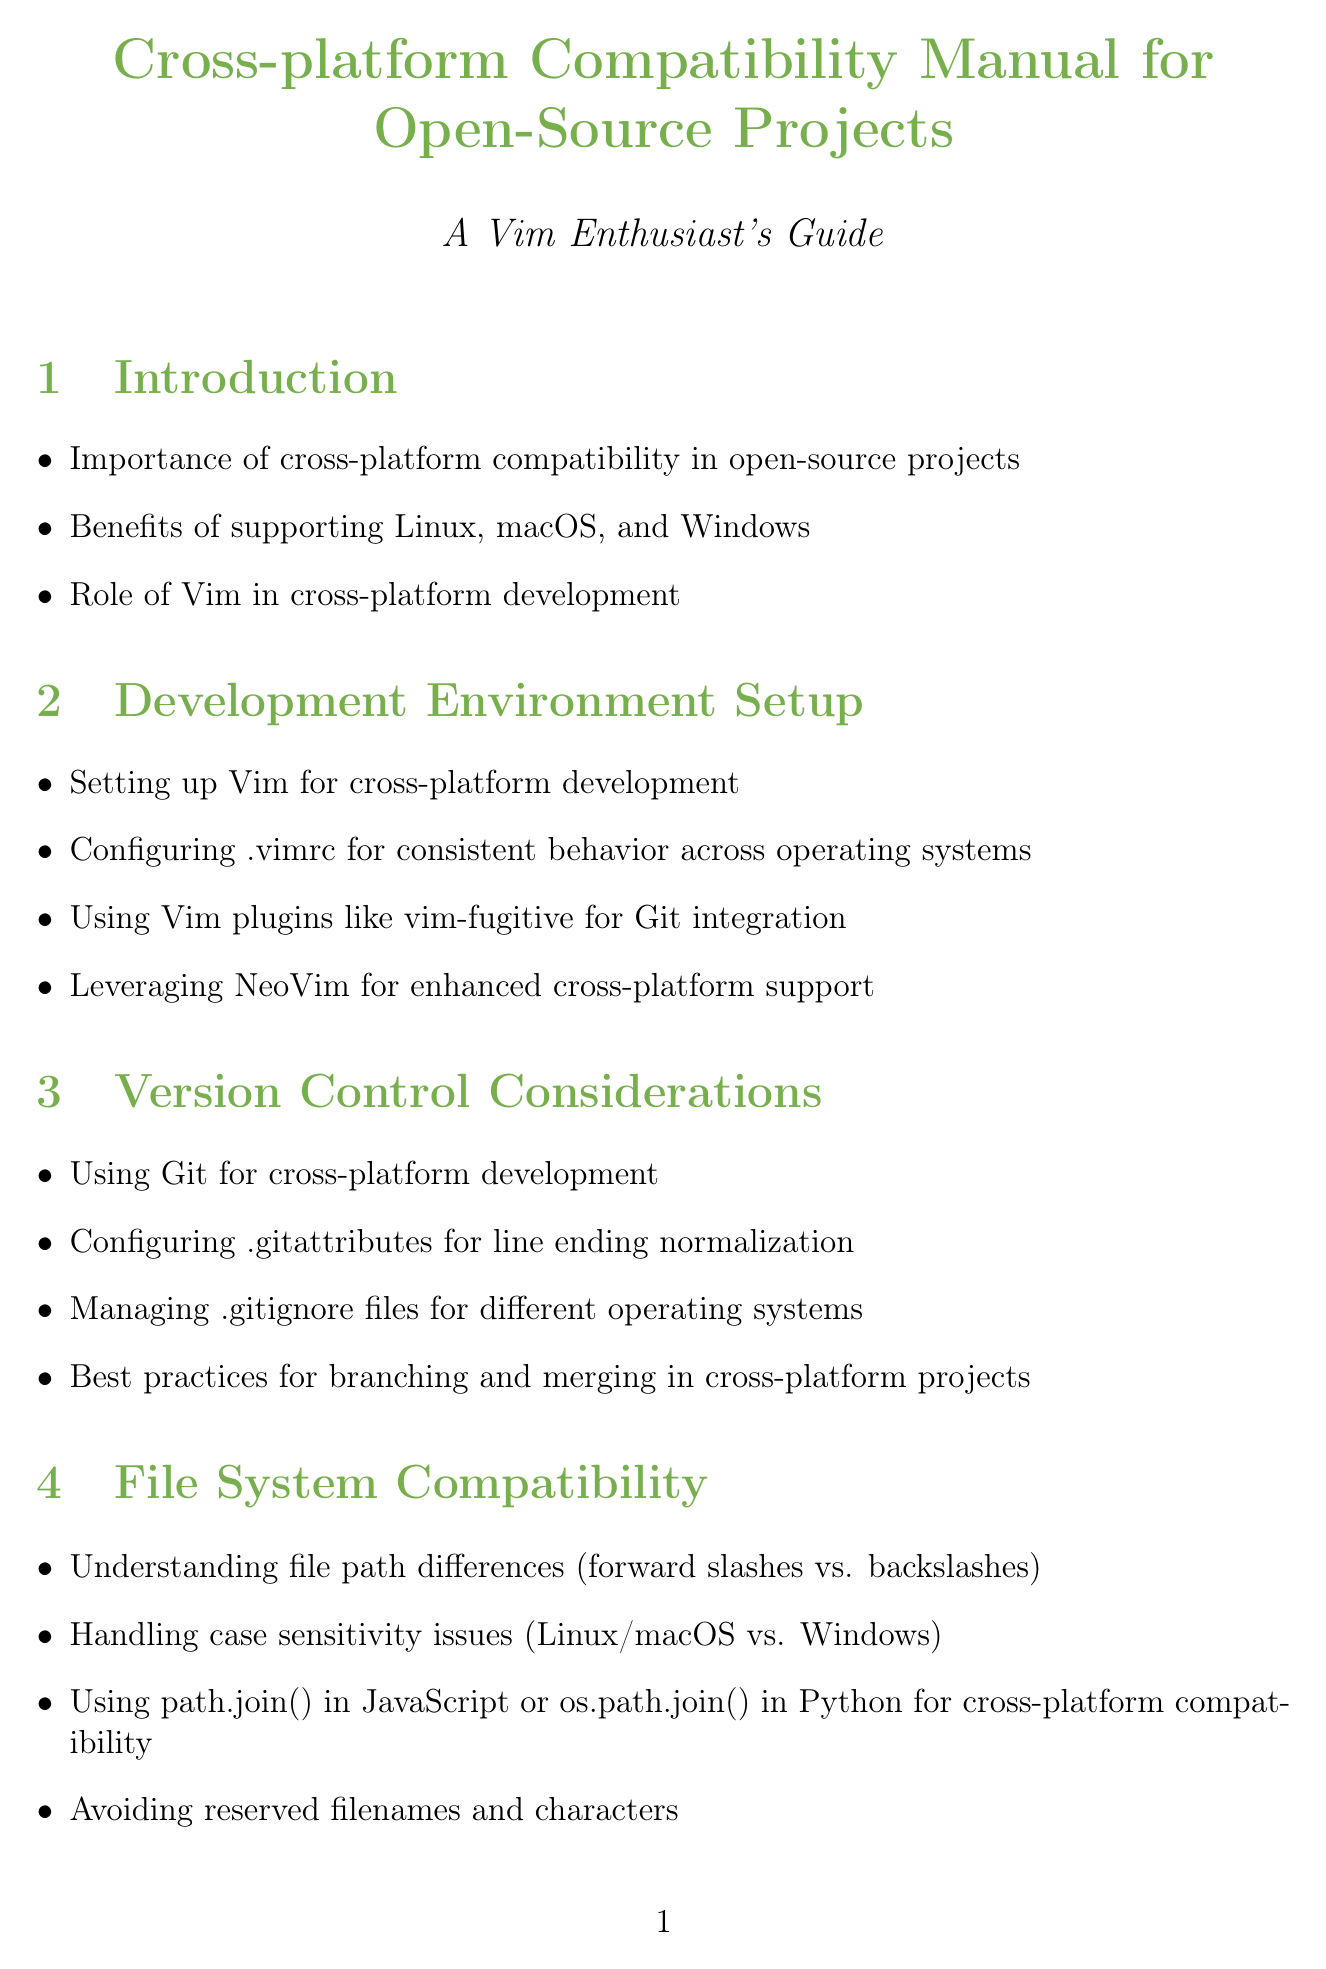What is the title of the manual? The title of the manual is explicitly stated at the beginning, which is "Cross-platform Compatibility Manual for Open-Source Projects."
Answer: Cross-platform Compatibility Manual for Open-Source Projects How many sections are in the document? The document contains a total of 11 sections listed under "sections."
Answer: 11 What is one of the benefits of cross-platform compatibility? The document mentions several benefits of supporting various operating systems, one of which is the increased accessibility for users.
Answer: Increased accessibility Which Vim plugin is mentioned for Git integration? In the "Development Environment Setup" section, the document explicitly states "vim-fugitive" as a recommended plugin.
Answer: vim-fugitive What command is suggested for path compatibility on Windows? The document under "Vim-specific Considerations" references the 'shellslash' option for path compatibility on Windows.
Answer: shellslash What is a common tool mentioned for documentation generation? The document lists "Doxygen" as one of the tools available for generating documentation.
Answer: Doxygen What type of pipelines does Jenkins support in this context? The document mentions "cross-platform CI/CD pipelines" as a specific type that Jenkins can set up.
Answer: Cross-platform CI/CD pipelines Name a cloud-based testing service mentioned in the document. The document refers to "Travis CI" and "AppVeyor" as examples of cloud-based testing services.
Answer: Travis CI What should be handled according to the section on file system compatibility? The section emphasizes the importance of handling "case sensitivity issues" in file systems.
Answer: Case sensitivity issues 